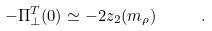<formula> <loc_0><loc_0><loc_500><loc_500>- \Pi ^ { T } _ { \perp } ( 0 ) \simeq - 2 z _ { 2 } ( m _ { \rho } ) \quad \ .</formula> 